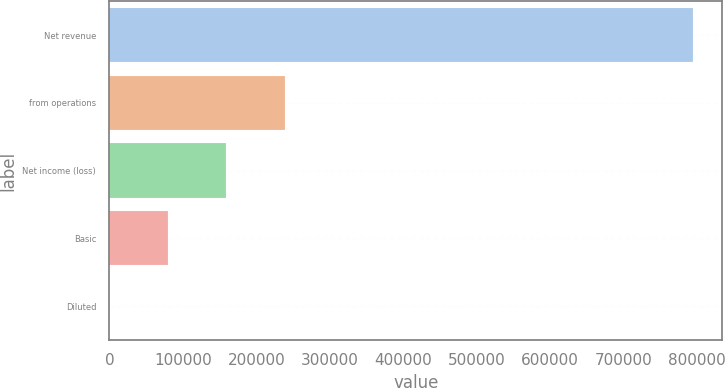<chart> <loc_0><loc_0><loc_500><loc_500><bar_chart><fcel>Net revenue<fcel>from operations<fcel>Net income (loss)<fcel>Basic<fcel>Diluted<nl><fcel>794676<fcel>238404<fcel>158936<fcel>79468.5<fcel>1<nl></chart> 